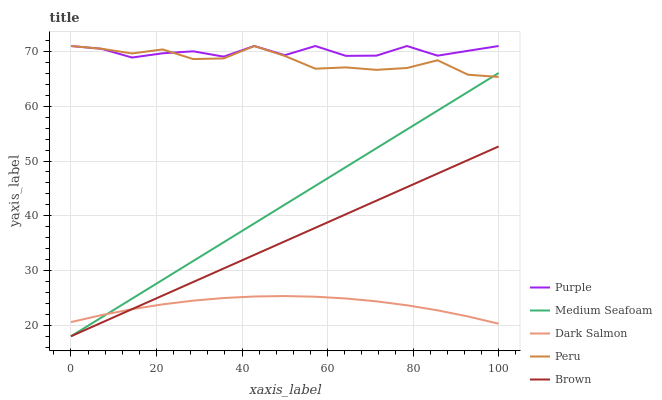Does Dark Salmon have the minimum area under the curve?
Answer yes or no. Yes. Does Purple have the maximum area under the curve?
Answer yes or no. Yes. Does Brown have the minimum area under the curve?
Answer yes or no. No. Does Brown have the maximum area under the curve?
Answer yes or no. No. Is Brown the smoothest?
Answer yes or no. Yes. Is Purple the roughest?
Answer yes or no. Yes. Is Medium Seafoam the smoothest?
Answer yes or no. No. Is Medium Seafoam the roughest?
Answer yes or no. No. Does Brown have the lowest value?
Answer yes or no. Yes. Does Peru have the lowest value?
Answer yes or no. No. Does Peru have the highest value?
Answer yes or no. Yes. Does Brown have the highest value?
Answer yes or no. No. Is Dark Salmon less than Peru?
Answer yes or no. Yes. Is Purple greater than Brown?
Answer yes or no. Yes. Does Medium Seafoam intersect Brown?
Answer yes or no. Yes. Is Medium Seafoam less than Brown?
Answer yes or no. No. Is Medium Seafoam greater than Brown?
Answer yes or no. No. Does Dark Salmon intersect Peru?
Answer yes or no. No. 